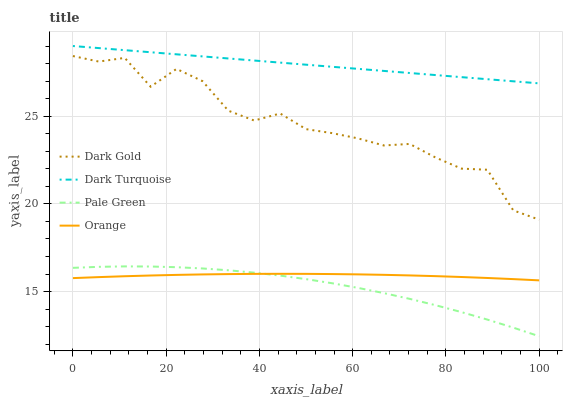Does Pale Green have the minimum area under the curve?
Answer yes or no. Yes. Does Dark Turquoise have the maximum area under the curve?
Answer yes or no. Yes. Does Dark Turquoise have the minimum area under the curve?
Answer yes or no. No. Does Pale Green have the maximum area under the curve?
Answer yes or no. No. Is Dark Turquoise the smoothest?
Answer yes or no. Yes. Is Dark Gold the roughest?
Answer yes or no. Yes. Is Pale Green the smoothest?
Answer yes or no. No. Is Pale Green the roughest?
Answer yes or no. No. Does Pale Green have the lowest value?
Answer yes or no. Yes. Does Dark Turquoise have the lowest value?
Answer yes or no. No. Does Dark Turquoise have the highest value?
Answer yes or no. Yes. Does Pale Green have the highest value?
Answer yes or no. No. Is Dark Gold less than Dark Turquoise?
Answer yes or no. Yes. Is Dark Gold greater than Orange?
Answer yes or no. Yes. Does Pale Green intersect Orange?
Answer yes or no. Yes. Is Pale Green less than Orange?
Answer yes or no. No. Is Pale Green greater than Orange?
Answer yes or no. No. Does Dark Gold intersect Dark Turquoise?
Answer yes or no. No. 